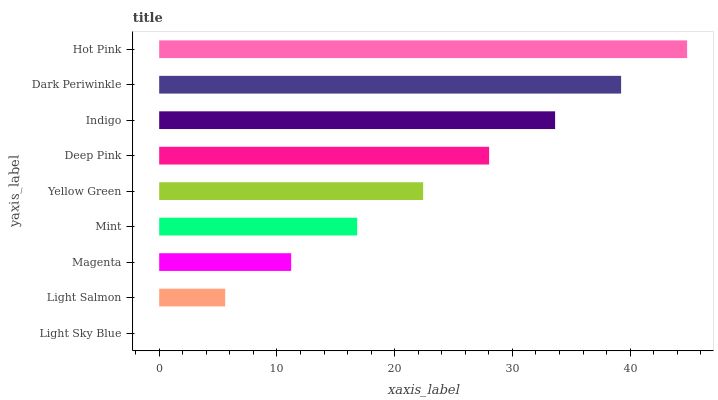Is Light Sky Blue the minimum?
Answer yes or no. Yes. Is Hot Pink the maximum?
Answer yes or no. Yes. Is Light Salmon the minimum?
Answer yes or no. No. Is Light Salmon the maximum?
Answer yes or no. No. Is Light Salmon greater than Light Sky Blue?
Answer yes or no. Yes. Is Light Sky Blue less than Light Salmon?
Answer yes or no. Yes. Is Light Sky Blue greater than Light Salmon?
Answer yes or no. No. Is Light Salmon less than Light Sky Blue?
Answer yes or no. No. Is Yellow Green the high median?
Answer yes or no. Yes. Is Yellow Green the low median?
Answer yes or no. Yes. Is Indigo the high median?
Answer yes or no. No. Is Light Salmon the low median?
Answer yes or no. No. 